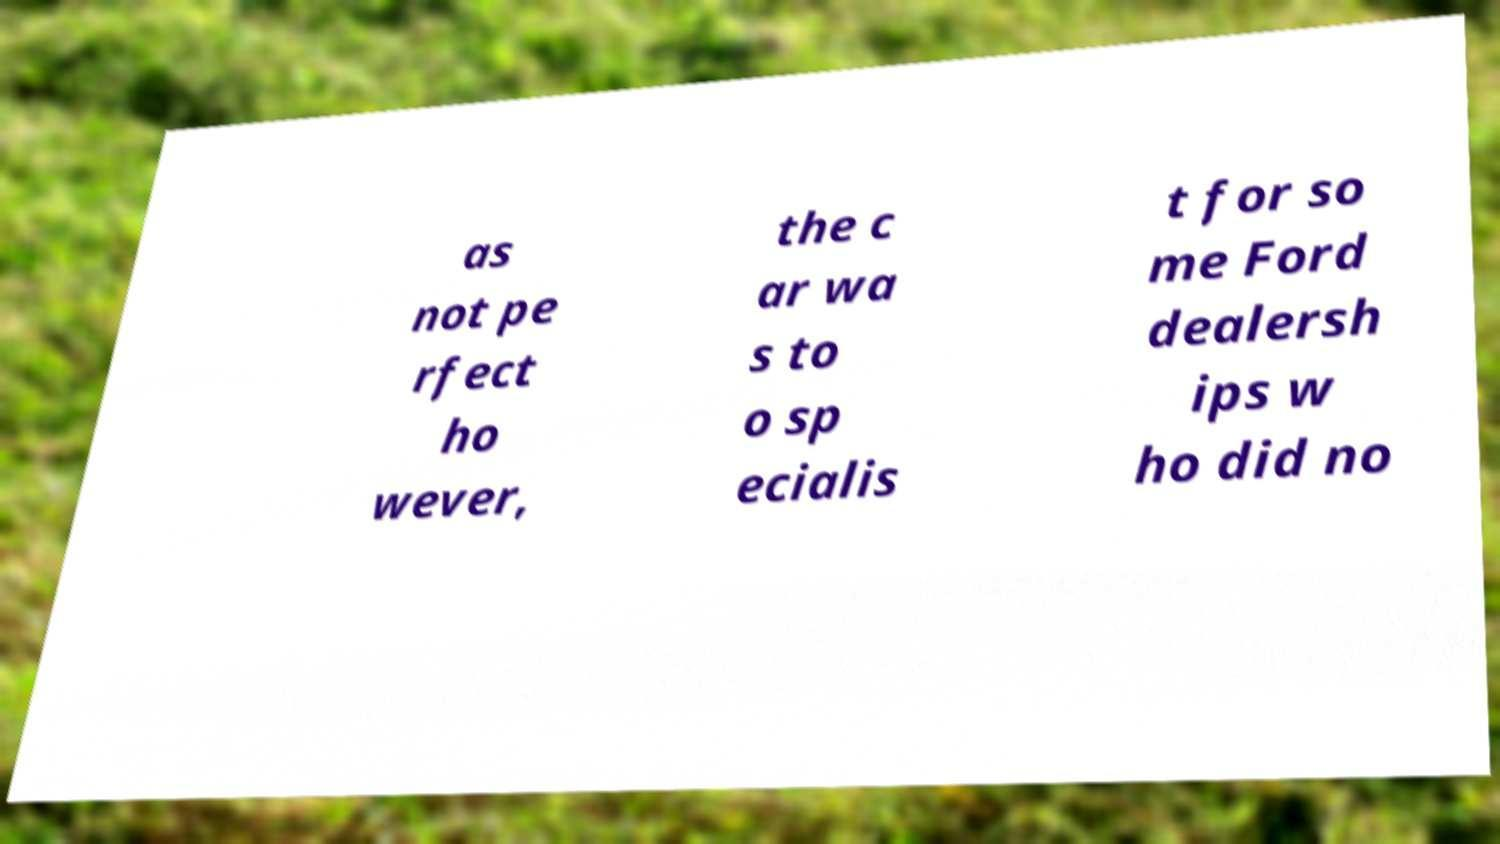Could you assist in decoding the text presented in this image and type it out clearly? as not pe rfect ho wever, the c ar wa s to o sp ecialis t for so me Ford dealersh ips w ho did no 